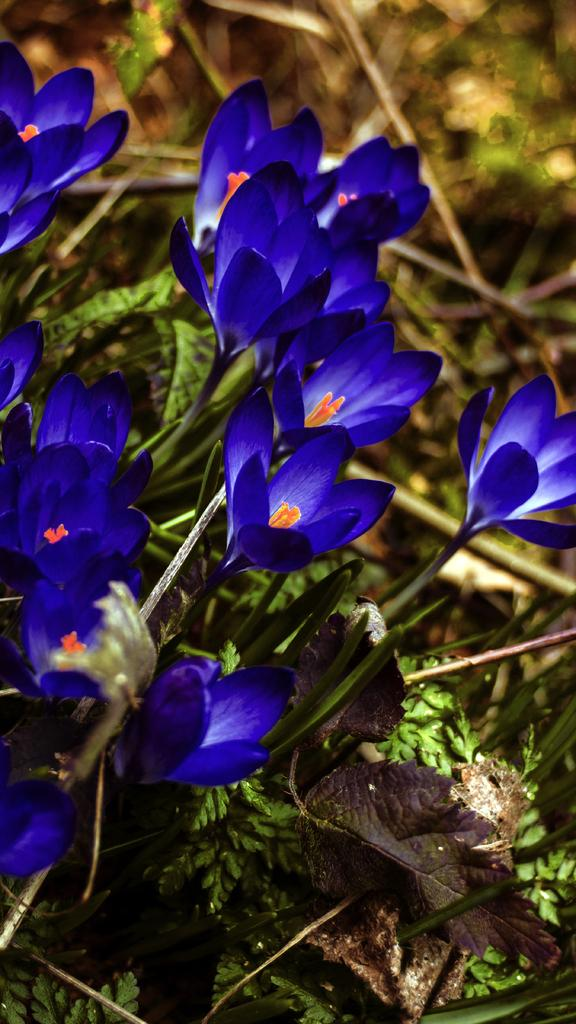What colors of flowers can be seen in the image? There are blue, white, and yellow flowers in the image. Are the flowers growing on any specific type of plant? Yes, the flowers are on plants. What can be observed about the background of the image? The background of the image is blurred. What type of soup is being served in the bucket in the image? There is no bucket or soup present in the image; it features flowers on plants with a blurred background. 